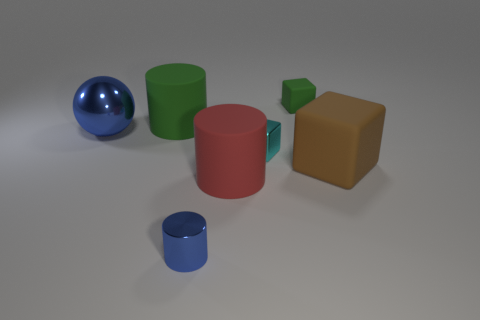Add 2 purple matte cubes. How many objects exist? 9 Subtract all balls. How many objects are left? 6 Subtract all small yellow cylinders. Subtract all brown cubes. How many objects are left? 6 Add 5 small cyan cubes. How many small cyan cubes are left? 6 Add 3 brown rubber cubes. How many brown rubber cubes exist? 4 Subtract 0 gray blocks. How many objects are left? 7 